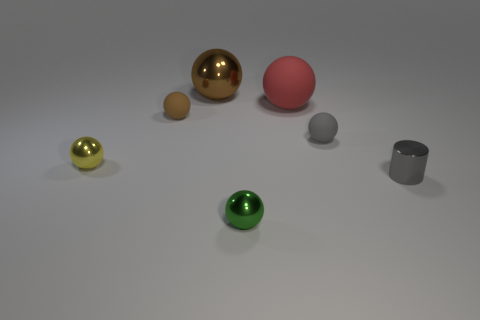Subtract all red rubber spheres. How many spheres are left? 5 Subtract all purple cylinders. How many brown balls are left? 2 Subtract all yellow spheres. How many spheres are left? 5 Subtract 1 spheres. How many spheres are left? 5 Add 3 green metallic things. How many objects exist? 10 Subtract all green balls. Subtract all green cubes. How many balls are left? 5 Subtract all cylinders. How many objects are left? 6 Add 6 small yellow spheres. How many small yellow spheres exist? 7 Subtract 0 blue cubes. How many objects are left? 7 Subtract all purple rubber spheres. Subtract all small rubber objects. How many objects are left? 5 